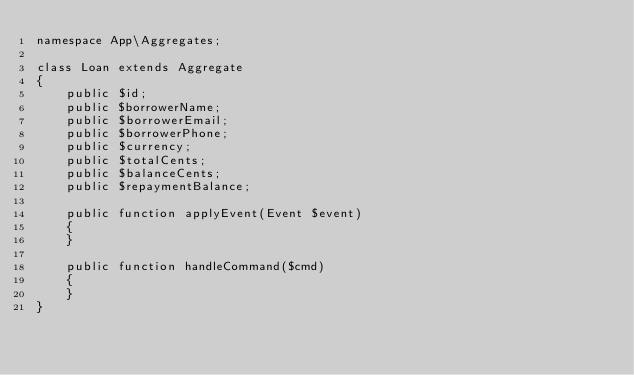<code> <loc_0><loc_0><loc_500><loc_500><_PHP_>namespace App\Aggregates;

class Loan extends Aggregate
{
    public $id;
    public $borrowerName;
    public $borrowerEmail;
    public $borrowerPhone;
    public $currency;
    public $totalCents;
    public $balanceCents;
    public $repaymentBalance;

    public function applyEvent(Event $event)
    {
    }

    public function handleCommand($cmd)
    {
    }
}
</code> 